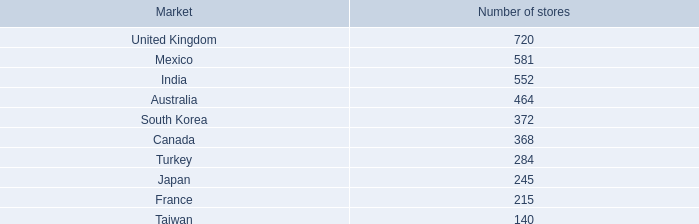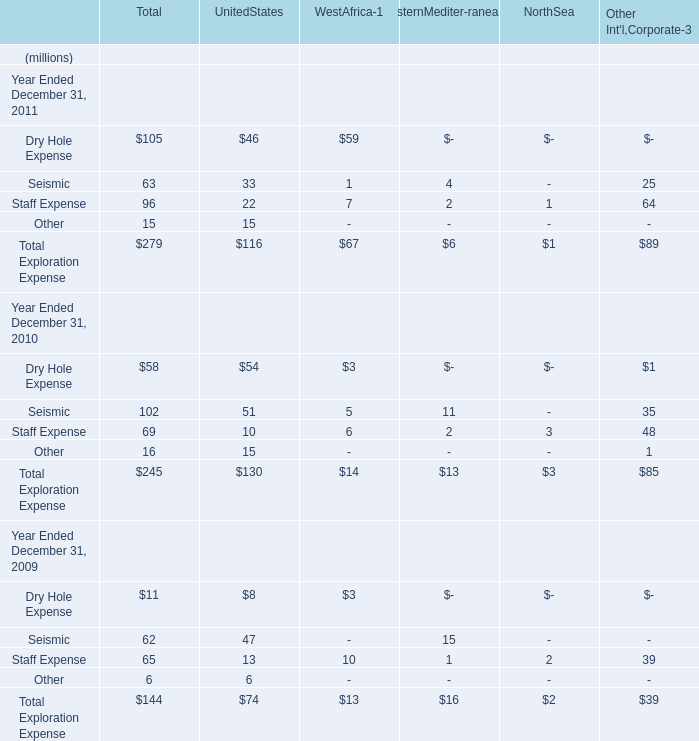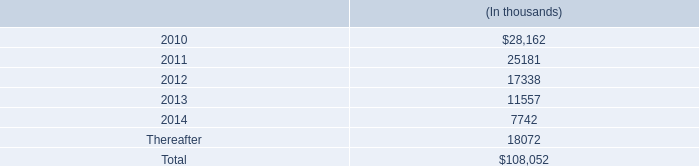capital leases covering buildings and machinery and equipment in millions totaled what for 2009 and 2008? 
Computations: (23.1 + 23.7)
Answer: 46.8. 